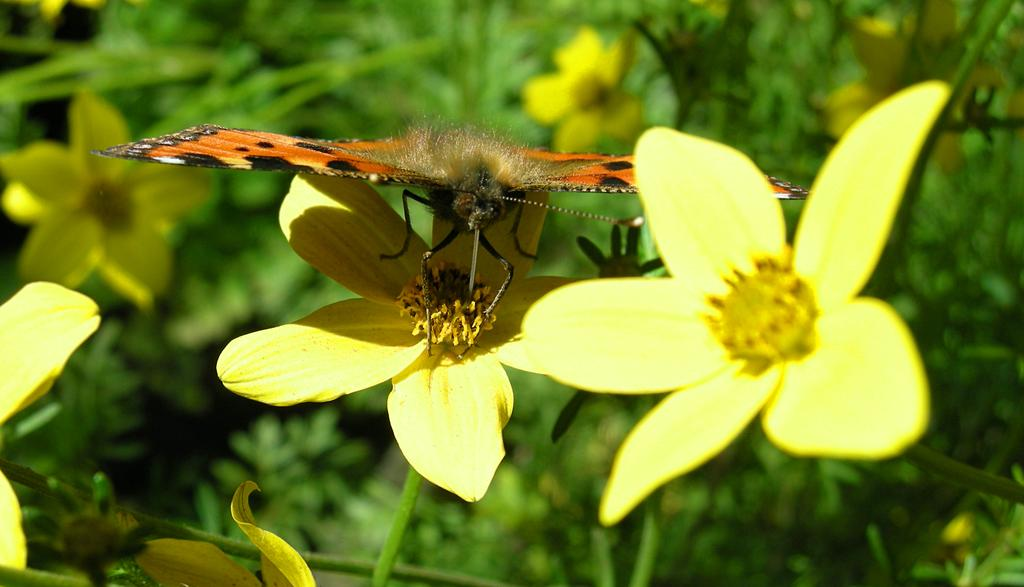What type of animal can be seen in the image? There is a butterfly in the image. What other living organisms are present in the image? There are flowers in the image. What can be seen in the background of the image? There are plants in the background of the image. What type of spoon is being used to eat the popcorn in the image? There is no spoon or popcorn present in the image. 